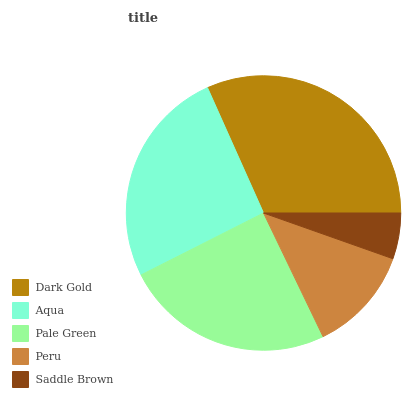Is Saddle Brown the minimum?
Answer yes or no. Yes. Is Dark Gold the maximum?
Answer yes or no. Yes. Is Aqua the minimum?
Answer yes or no. No. Is Aqua the maximum?
Answer yes or no. No. Is Dark Gold greater than Aqua?
Answer yes or no. Yes. Is Aqua less than Dark Gold?
Answer yes or no. Yes. Is Aqua greater than Dark Gold?
Answer yes or no. No. Is Dark Gold less than Aqua?
Answer yes or no. No. Is Pale Green the high median?
Answer yes or no. Yes. Is Pale Green the low median?
Answer yes or no. Yes. Is Peru the high median?
Answer yes or no. No. Is Dark Gold the low median?
Answer yes or no. No. 